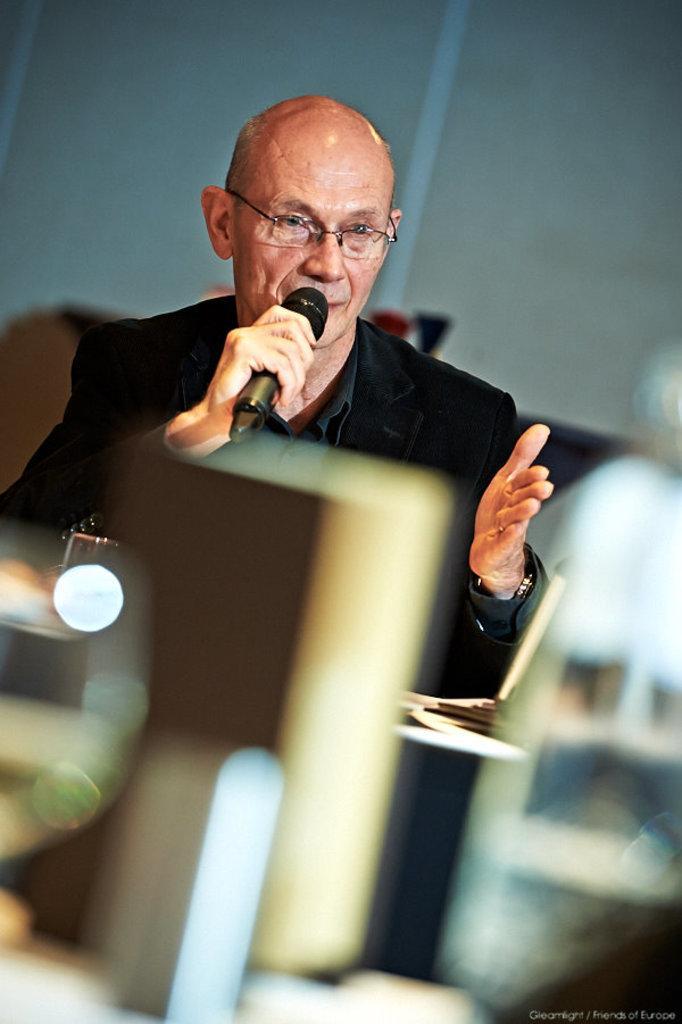Can you describe this image briefly? In this image I can see a person wearing a black color jacket and wearing a spectacles and holding a mike on his hand. 